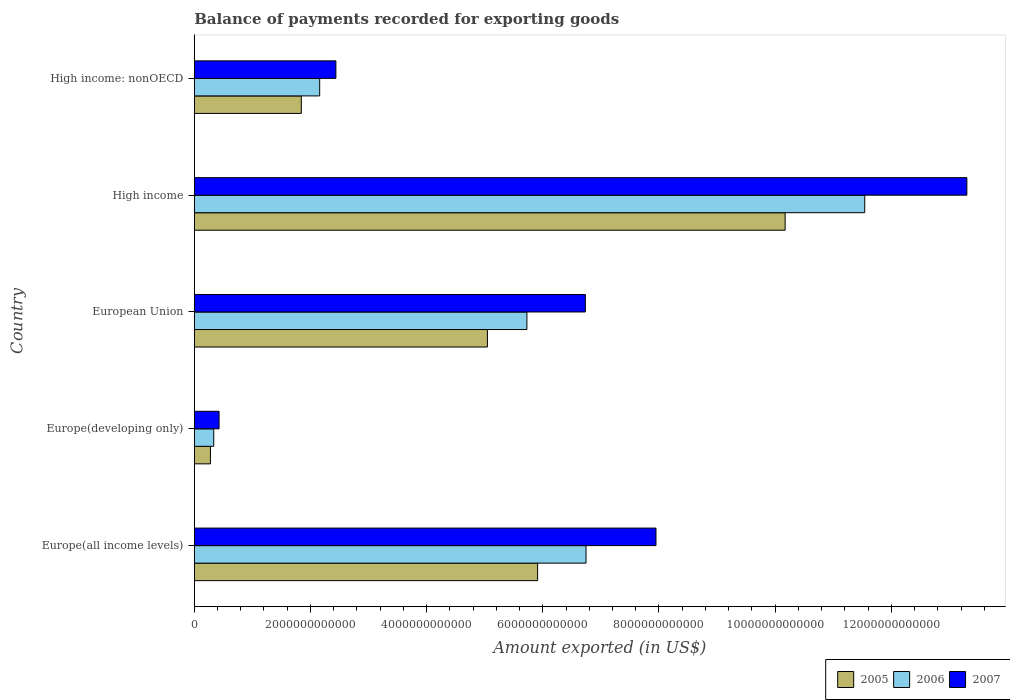How many groups of bars are there?
Offer a terse response. 5. What is the label of the 4th group of bars from the top?
Give a very brief answer. Europe(developing only). What is the amount exported in 2006 in High income: nonOECD?
Offer a very short reply. 2.16e+12. Across all countries, what is the maximum amount exported in 2005?
Ensure brevity in your answer.  1.02e+13. Across all countries, what is the minimum amount exported in 2005?
Your answer should be very brief. 2.78e+11. In which country was the amount exported in 2005 maximum?
Your answer should be compact. High income. In which country was the amount exported in 2007 minimum?
Your answer should be compact. Europe(developing only). What is the total amount exported in 2007 in the graph?
Offer a terse response. 3.08e+13. What is the difference between the amount exported in 2007 in Europe(all income levels) and that in High income?
Your response must be concise. -5.35e+12. What is the difference between the amount exported in 2007 in High income and the amount exported in 2005 in Europe(developing only)?
Your answer should be compact. 1.30e+13. What is the average amount exported in 2006 per country?
Keep it short and to the point. 5.30e+12. What is the difference between the amount exported in 2005 and amount exported in 2006 in Europe(developing only)?
Offer a terse response. -5.70e+1. What is the ratio of the amount exported in 2007 in Europe(developing only) to that in High income: nonOECD?
Your answer should be compact. 0.18. Is the amount exported in 2007 in Europe(all income levels) less than that in Europe(developing only)?
Make the answer very short. No. What is the difference between the highest and the second highest amount exported in 2006?
Give a very brief answer. 4.80e+12. What is the difference between the highest and the lowest amount exported in 2006?
Keep it short and to the point. 1.12e+13. In how many countries, is the amount exported in 2005 greater than the average amount exported in 2005 taken over all countries?
Keep it short and to the point. 3. Is the sum of the amount exported in 2007 in Europe(developing only) and High income: nonOECD greater than the maximum amount exported in 2006 across all countries?
Offer a terse response. No. What is the difference between two consecutive major ticks on the X-axis?
Give a very brief answer. 2.00e+12. Does the graph contain any zero values?
Make the answer very short. No. Does the graph contain grids?
Your answer should be very brief. No. What is the title of the graph?
Offer a terse response. Balance of payments recorded for exporting goods. What is the label or title of the X-axis?
Keep it short and to the point. Amount exported (in US$). What is the Amount exported (in US$) of 2005 in Europe(all income levels)?
Offer a terse response. 5.91e+12. What is the Amount exported (in US$) in 2006 in Europe(all income levels)?
Your answer should be compact. 6.74e+12. What is the Amount exported (in US$) of 2007 in Europe(all income levels)?
Provide a short and direct response. 7.95e+12. What is the Amount exported (in US$) in 2005 in Europe(developing only)?
Your answer should be very brief. 2.78e+11. What is the Amount exported (in US$) of 2006 in Europe(developing only)?
Provide a succinct answer. 3.35e+11. What is the Amount exported (in US$) of 2007 in Europe(developing only)?
Keep it short and to the point. 4.27e+11. What is the Amount exported (in US$) of 2005 in European Union?
Your answer should be compact. 5.05e+12. What is the Amount exported (in US$) of 2006 in European Union?
Offer a terse response. 5.73e+12. What is the Amount exported (in US$) of 2007 in European Union?
Ensure brevity in your answer.  6.73e+12. What is the Amount exported (in US$) in 2005 in High income?
Your answer should be compact. 1.02e+13. What is the Amount exported (in US$) in 2006 in High income?
Provide a short and direct response. 1.15e+13. What is the Amount exported (in US$) of 2007 in High income?
Provide a succinct answer. 1.33e+13. What is the Amount exported (in US$) of 2005 in High income: nonOECD?
Provide a short and direct response. 1.84e+12. What is the Amount exported (in US$) in 2006 in High income: nonOECD?
Your answer should be compact. 2.16e+12. What is the Amount exported (in US$) in 2007 in High income: nonOECD?
Provide a succinct answer. 2.44e+12. Across all countries, what is the maximum Amount exported (in US$) of 2005?
Offer a terse response. 1.02e+13. Across all countries, what is the maximum Amount exported (in US$) of 2006?
Your answer should be compact. 1.15e+13. Across all countries, what is the maximum Amount exported (in US$) of 2007?
Your answer should be very brief. 1.33e+13. Across all countries, what is the minimum Amount exported (in US$) in 2005?
Provide a short and direct response. 2.78e+11. Across all countries, what is the minimum Amount exported (in US$) of 2006?
Provide a succinct answer. 3.35e+11. Across all countries, what is the minimum Amount exported (in US$) in 2007?
Make the answer very short. 4.27e+11. What is the total Amount exported (in US$) of 2005 in the graph?
Provide a short and direct response. 2.33e+13. What is the total Amount exported (in US$) in 2006 in the graph?
Make the answer very short. 2.65e+13. What is the total Amount exported (in US$) in 2007 in the graph?
Your answer should be very brief. 3.08e+13. What is the difference between the Amount exported (in US$) of 2005 in Europe(all income levels) and that in Europe(developing only)?
Keep it short and to the point. 5.63e+12. What is the difference between the Amount exported (in US$) of 2006 in Europe(all income levels) and that in Europe(developing only)?
Make the answer very short. 6.41e+12. What is the difference between the Amount exported (in US$) in 2007 in Europe(all income levels) and that in Europe(developing only)?
Provide a short and direct response. 7.52e+12. What is the difference between the Amount exported (in US$) in 2005 in Europe(all income levels) and that in European Union?
Provide a short and direct response. 8.64e+11. What is the difference between the Amount exported (in US$) in 2006 in Europe(all income levels) and that in European Union?
Ensure brevity in your answer.  1.02e+12. What is the difference between the Amount exported (in US$) of 2007 in Europe(all income levels) and that in European Union?
Offer a very short reply. 1.22e+12. What is the difference between the Amount exported (in US$) of 2005 in Europe(all income levels) and that in High income?
Ensure brevity in your answer.  -4.26e+12. What is the difference between the Amount exported (in US$) in 2006 in Europe(all income levels) and that in High income?
Make the answer very short. -4.80e+12. What is the difference between the Amount exported (in US$) of 2007 in Europe(all income levels) and that in High income?
Offer a terse response. -5.35e+12. What is the difference between the Amount exported (in US$) of 2005 in Europe(all income levels) and that in High income: nonOECD?
Offer a terse response. 4.07e+12. What is the difference between the Amount exported (in US$) in 2006 in Europe(all income levels) and that in High income: nonOECD?
Offer a very short reply. 4.59e+12. What is the difference between the Amount exported (in US$) in 2007 in Europe(all income levels) and that in High income: nonOECD?
Your answer should be compact. 5.51e+12. What is the difference between the Amount exported (in US$) of 2005 in Europe(developing only) and that in European Union?
Offer a very short reply. -4.77e+12. What is the difference between the Amount exported (in US$) of 2006 in Europe(developing only) and that in European Union?
Make the answer very short. -5.39e+12. What is the difference between the Amount exported (in US$) in 2007 in Europe(developing only) and that in European Union?
Keep it short and to the point. -6.31e+12. What is the difference between the Amount exported (in US$) in 2005 in Europe(developing only) and that in High income?
Provide a succinct answer. -9.89e+12. What is the difference between the Amount exported (in US$) in 2006 in Europe(developing only) and that in High income?
Ensure brevity in your answer.  -1.12e+13. What is the difference between the Amount exported (in US$) of 2007 in Europe(developing only) and that in High income?
Offer a very short reply. -1.29e+13. What is the difference between the Amount exported (in US$) in 2005 in Europe(developing only) and that in High income: nonOECD?
Offer a terse response. -1.56e+12. What is the difference between the Amount exported (in US$) of 2006 in Europe(developing only) and that in High income: nonOECD?
Keep it short and to the point. -1.82e+12. What is the difference between the Amount exported (in US$) in 2007 in Europe(developing only) and that in High income: nonOECD?
Ensure brevity in your answer.  -2.01e+12. What is the difference between the Amount exported (in US$) of 2005 in European Union and that in High income?
Ensure brevity in your answer.  -5.13e+12. What is the difference between the Amount exported (in US$) in 2006 in European Union and that in High income?
Keep it short and to the point. -5.82e+12. What is the difference between the Amount exported (in US$) of 2007 in European Union and that in High income?
Provide a succinct answer. -6.57e+12. What is the difference between the Amount exported (in US$) in 2005 in European Union and that in High income: nonOECD?
Offer a terse response. 3.20e+12. What is the difference between the Amount exported (in US$) of 2006 in European Union and that in High income: nonOECD?
Offer a very short reply. 3.57e+12. What is the difference between the Amount exported (in US$) in 2007 in European Union and that in High income: nonOECD?
Your response must be concise. 4.29e+12. What is the difference between the Amount exported (in US$) in 2005 in High income and that in High income: nonOECD?
Your response must be concise. 8.33e+12. What is the difference between the Amount exported (in US$) of 2006 in High income and that in High income: nonOECD?
Make the answer very short. 9.38e+12. What is the difference between the Amount exported (in US$) of 2007 in High income and that in High income: nonOECD?
Provide a short and direct response. 1.09e+13. What is the difference between the Amount exported (in US$) in 2005 in Europe(all income levels) and the Amount exported (in US$) in 2006 in Europe(developing only)?
Ensure brevity in your answer.  5.58e+12. What is the difference between the Amount exported (in US$) of 2005 in Europe(all income levels) and the Amount exported (in US$) of 2007 in Europe(developing only)?
Offer a very short reply. 5.48e+12. What is the difference between the Amount exported (in US$) in 2006 in Europe(all income levels) and the Amount exported (in US$) in 2007 in Europe(developing only)?
Your response must be concise. 6.32e+12. What is the difference between the Amount exported (in US$) in 2005 in Europe(all income levels) and the Amount exported (in US$) in 2006 in European Union?
Your response must be concise. 1.84e+11. What is the difference between the Amount exported (in US$) of 2005 in Europe(all income levels) and the Amount exported (in US$) of 2007 in European Union?
Keep it short and to the point. -8.22e+11. What is the difference between the Amount exported (in US$) of 2006 in Europe(all income levels) and the Amount exported (in US$) of 2007 in European Union?
Ensure brevity in your answer.  1.16e+1. What is the difference between the Amount exported (in US$) in 2005 in Europe(all income levels) and the Amount exported (in US$) in 2006 in High income?
Provide a succinct answer. -5.63e+12. What is the difference between the Amount exported (in US$) in 2005 in Europe(all income levels) and the Amount exported (in US$) in 2007 in High income?
Provide a short and direct response. -7.39e+12. What is the difference between the Amount exported (in US$) of 2006 in Europe(all income levels) and the Amount exported (in US$) of 2007 in High income?
Offer a terse response. -6.56e+12. What is the difference between the Amount exported (in US$) of 2005 in Europe(all income levels) and the Amount exported (in US$) of 2006 in High income: nonOECD?
Give a very brief answer. 3.75e+12. What is the difference between the Amount exported (in US$) of 2005 in Europe(all income levels) and the Amount exported (in US$) of 2007 in High income: nonOECD?
Make the answer very short. 3.47e+12. What is the difference between the Amount exported (in US$) in 2006 in Europe(all income levels) and the Amount exported (in US$) in 2007 in High income: nonOECD?
Ensure brevity in your answer.  4.31e+12. What is the difference between the Amount exported (in US$) in 2005 in Europe(developing only) and the Amount exported (in US$) in 2006 in European Union?
Provide a short and direct response. -5.45e+12. What is the difference between the Amount exported (in US$) of 2005 in Europe(developing only) and the Amount exported (in US$) of 2007 in European Union?
Make the answer very short. -6.45e+12. What is the difference between the Amount exported (in US$) in 2006 in Europe(developing only) and the Amount exported (in US$) in 2007 in European Union?
Your answer should be compact. -6.40e+12. What is the difference between the Amount exported (in US$) of 2005 in Europe(developing only) and the Amount exported (in US$) of 2006 in High income?
Provide a succinct answer. -1.13e+13. What is the difference between the Amount exported (in US$) in 2005 in Europe(developing only) and the Amount exported (in US$) in 2007 in High income?
Make the answer very short. -1.30e+13. What is the difference between the Amount exported (in US$) in 2006 in Europe(developing only) and the Amount exported (in US$) in 2007 in High income?
Offer a very short reply. -1.30e+13. What is the difference between the Amount exported (in US$) of 2005 in Europe(developing only) and the Amount exported (in US$) of 2006 in High income: nonOECD?
Your answer should be compact. -1.88e+12. What is the difference between the Amount exported (in US$) in 2005 in Europe(developing only) and the Amount exported (in US$) in 2007 in High income: nonOECD?
Provide a succinct answer. -2.16e+12. What is the difference between the Amount exported (in US$) in 2006 in Europe(developing only) and the Amount exported (in US$) in 2007 in High income: nonOECD?
Your answer should be compact. -2.10e+12. What is the difference between the Amount exported (in US$) of 2005 in European Union and the Amount exported (in US$) of 2006 in High income?
Ensure brevity in your answer.  -6.50e+12. What is the difference between the Amount exported (in US$) in 2005 in European Union and the Amount exported (in US$) in 2007 in High income?
Provide a succinct answer. -8.25e+12. What is the difference between the Amount exported (in US$) of 2006 in European Union and the Amount exported (in US$) of 2007 in High income?
Your answer should be compact. -7.57e+12. What is the difference between the Amount exported (in US$) of 2005 in European Union and the Amount exported (in US$) of 2006 in High income: nonOECD?
Provide a short and direct response. 2.89e+12. What is the difference between the Amount exported (in US$) in 2005 in European Union and the Amount exported (in US$) in 2007 in High income: nonOECD?
Offer a terse response. 2.61e+12. What is the difference between the Amount exported (in US$) of 2006 in European Union and the Amount exported (in US$) of 2007 in High income: nonOECD?
Provide a short and direct response. 3.29e+12. What is the difference between the Amount exported (in US$) in 2005 in High income and the Amount exported (in US$) in 2006 in High income: nonOECD?
Your answer should be very brief. 8.01e+12. What is the difference between the Amount exported (in US$) of 2005 in High income and the Amount exported (in US$) of 2007 in High income: nonOECD?
Offer a very short reply. 7.73e+12. What is the difference between the Amount exported (in US$) in 2006 in High income and the Amount exported (in US$) in 2007 in High income: nonOECD?
Offer a terse response. 9.10e+12. What is the average Amount exported (in US$) of 2005 per country?
Make the answer very short. 4.65e+12. What is the average Amount exported (in US$) in 2006 per country?
Give a very brief answer. 5.30e+12. What is the average Amount exported (in US$) in 2007 per country?
Give a very brief answer. 6.17e+12. What is the difference between the Amount exported (in US$) in 2005 and Amount exported (in US$) in 2006 in Europe(all income levels)?
Your response must be concise. -8.34e+11. What is the difference between the Amount exported (in US$) in 2005 and Amount exported (in US$) in 2007 in Europe(all income levels)?
Ensure brevity in your answer.  -2.04e+12. What is the difference between the Amount exported (in US$) in 2006 and Amount exported (in US$) in 2007 in Europe(all income levels)?
Offer a very short reply. -1.20e+12. What is the difference between the Amount exported (in US$) of 2005 and Amount exported (in US$) of 2006 in Europe(developing only)?
Keep it short and to the point. -5.70e+1. What is the difference between the Amount exported (in US$) in 2005 and Amount exported (in US$) in 2007 in Europe(developing only)?
Offer a terse response. -1.49e+11. What is the difference between the Amount exported (in US$) in 2006 and Amount exported (in US$) in 2007 in Europe(developing only)?
Give a very brief answer. -9.17e+1. What is the difference between the Amount exported (in US$) in 2005 and Amount exported (in US$) in 2006 in European Union?
Offer a very short reply. -6.80e+11. What is the difference between the Amount exported (in US$) of 2005 and Amount exported (in US$) of 2007 in European Union?
Your answer should be compact. -1.69e+12. What is the difference between the Amount exported (in US$) of 2006 and Amount exported (in US$) of 2007 in European Union?
Offer a terse response. -1.01e+12. What is the difference between the Amount exported (in US$) of 2005 and Amount exported (in US$) of 2006 in High income?
Make the answer very short. -1.37e+12. What is the difference between the Amount exported (in US$) in 2005 and Amount exported (in US$) in 2007 in High income?
Make the answer very short. -3.13e+12. What is the difference between the Amount exported (in US$) of 2006 and Amount exported (in US$) of 2007 in High income?
Your answer should be very brief. -1.76e+12. What is the difference between the Amount exported (in US$) in 2005 and Amount exported (in US$) in 2006 in High income: nonOECD?
Ensure brevity in your answer.  -3.16e+11. What is the difference between the Amount exported (in US$) in 2005 and Amount exported (in US$) in 2007 in High income: nonOECD?
Provide a short and direct response. -5.95e+11. What is the difference between the Amount exported (in US$) of 2006 and Amount exported (in US$) of 2007 in High income: nonOECD?
Offer a terse response. -2.79e+11. What is the ratio of the Amount exported (in US$) of 2005 in Europe(all income levels) to that in Europe(developing only)?
Make the answer very short. 21.23. What is the ratio of the Amount exported (in US$) in 2006 in Europe(all income levels) to that in Europe(developing only)?
Your answer should be compact. 20.11. What is the ratio of the Amount exported (in US$) of 2007 in Europe(all income levels) to that in Europe(developing only)?
Your answer should be very brief. 18.61. What is the ratio of the Amount exported (in US$) in 2005 in Europe(all income levels) to that in European Union?
Provide a short and direct response. 1.17. What is the ratio of the Amount exported (in US$) of 2006 in Europe(all income levels) to that in European Union?
Provide a succinct answer. 1.18. What is the ratio of the Amount exported (in US$) of 2007 in Europe(all income levels) to that in European Union?
Offer a very short reply. 1.18. What is the ratio of the Amount exported (in US$) of 2005 in Europe(all income levels) to that in High income?
Ensure brevity in your answer.  0.58. What is the ratio of the Amount exported (in US$) of 2006 in Europe(all income levels) to that in High income?
Keep it short and to the point. 0.58. What is the ratio of the Amount exported (in US$) in 2007 in Europe(all income levels) to that in High income?
Provide a succinct answer. 0.6. What is the ratio of the Amount exported (in US$) of 2005 in Europe(all income levels) to that in High income: nonOECD?
Make the answer very short. 3.21. What is the ratio of the Amount exported (in US$) of 2006 in Europe(all income levels) to that in High income: nonOECD?
Your answer should be compact. 3.12. What is the ratio of the Amount exported (in US$) in 2007 in Europe(all income levels) to that in High income: nonOECD?
Offer a terse response. 3.26. What is the ratio of the Amount exported (in US$) in 2005 in Europe(developing only) to that in European Union?
Ensure brevity in your answer.  0.06. What is the ratio of the Amount exported (in US$) in 2006 in Europe(developing only) to that in European Union?
Give a very brief answer. 0.06. What is the ratio of the Amount exported (in US$) in 2007 in Europe(developing only) to that in European Union?
Ensure brevity in your answer.  0.06. What is the ratio of the Amount exported (in US$) in 2005 in Europe(developing only) to that in High income?
Your answer should be very brief. 0.03. What is the ratio of the Amount exported (in US$) in 2006 in Europe(developing only) to that in High income?
Your answer should be very brief. 0.03. What is the ratio of the Amount exported (in US$) in 2007 in Europe(developing only) to that in High income?
Offer a terse response. 0.03. What is the ratio of the Amount exported (in US$) in 2005 in Europe(developing only) to that in High income: nonOECD?
Ensure brevity in your answer.  0.15. What is the ratio of the Amount exported (in US$) of 2006 in Europe(developing only) to that in High income: nonOECD?
Your answer should be very brief. 0.16. What is the ratio of the Amount exported (in US$) of 2007 in Europe(developing only) to that in High income: nonOECD?
Give a very brief answer. 0.18. What is the ratio of the Amount exported (in US$) in 2005 in European Union to that in High income?
Your answer should be compact. 0.5. What is the ratio of the Amount exported (in US$) in 2006 in European Union to that in High income?
Your answer should be compact. 0.5. What is the ratio of the Amount exported (in US$) of 2007 in European Union to that in High income?
Your answer should be compact. 0.51. What is the ratio of the Amount exported (in US$) in 2005 in European Union to that in High income: nonOECD?
Your answer should be compact. 2.74. What is the ratio of the Amount exported (in US$) of 2006 in European Union to that in High income: nonOECD?
Keep it short and to the point. 2.65. What is the ratio of the Amount exported (in US$) in 2007 in European Union to that in High income: nonOECD?
Your response must be concise. 2.76. What is the ratio of the Amount exported (in US$) in 2005 in High income to that in High income: nonOECD?
Your answer should be compact. 5.52. What is the ratio of the Amount exported (in US$) in 2006 in High income to that in High income: nonOECD?
Provide a short and direct response. 5.35. What is the ratio of the Amount exported (in US$) of 2007 in High income to that in High income: nonOECD?
Offer a terse response. 5.46. What is the difference between the highest and the second highest Amount exported (in US$) in 2005?
Provide a succinct answer. 4.26e+12. What is the difference between the highest and the second highest Amount exported (in US$) of 2006?
Provide a short and direct response. 4.80e+12. What is the difference between the highest and the second highest Amount exported (in US$) of 2007?
Your answer should be very brief. 5.35e+12. What is the difference between the highest and the lowest Amount exported (in US$) of 2005?
Your answer should be compact. 9.89e+12. What is the difference between the highest and the lowest Amount exported (in US$) of 2006?
Ensure brevity in your answer.  1.12e+13. What is the difference between the highest and the lowest Amount exported (in US$) in 2007?
Give a very brief answer. 1.29e+13. 